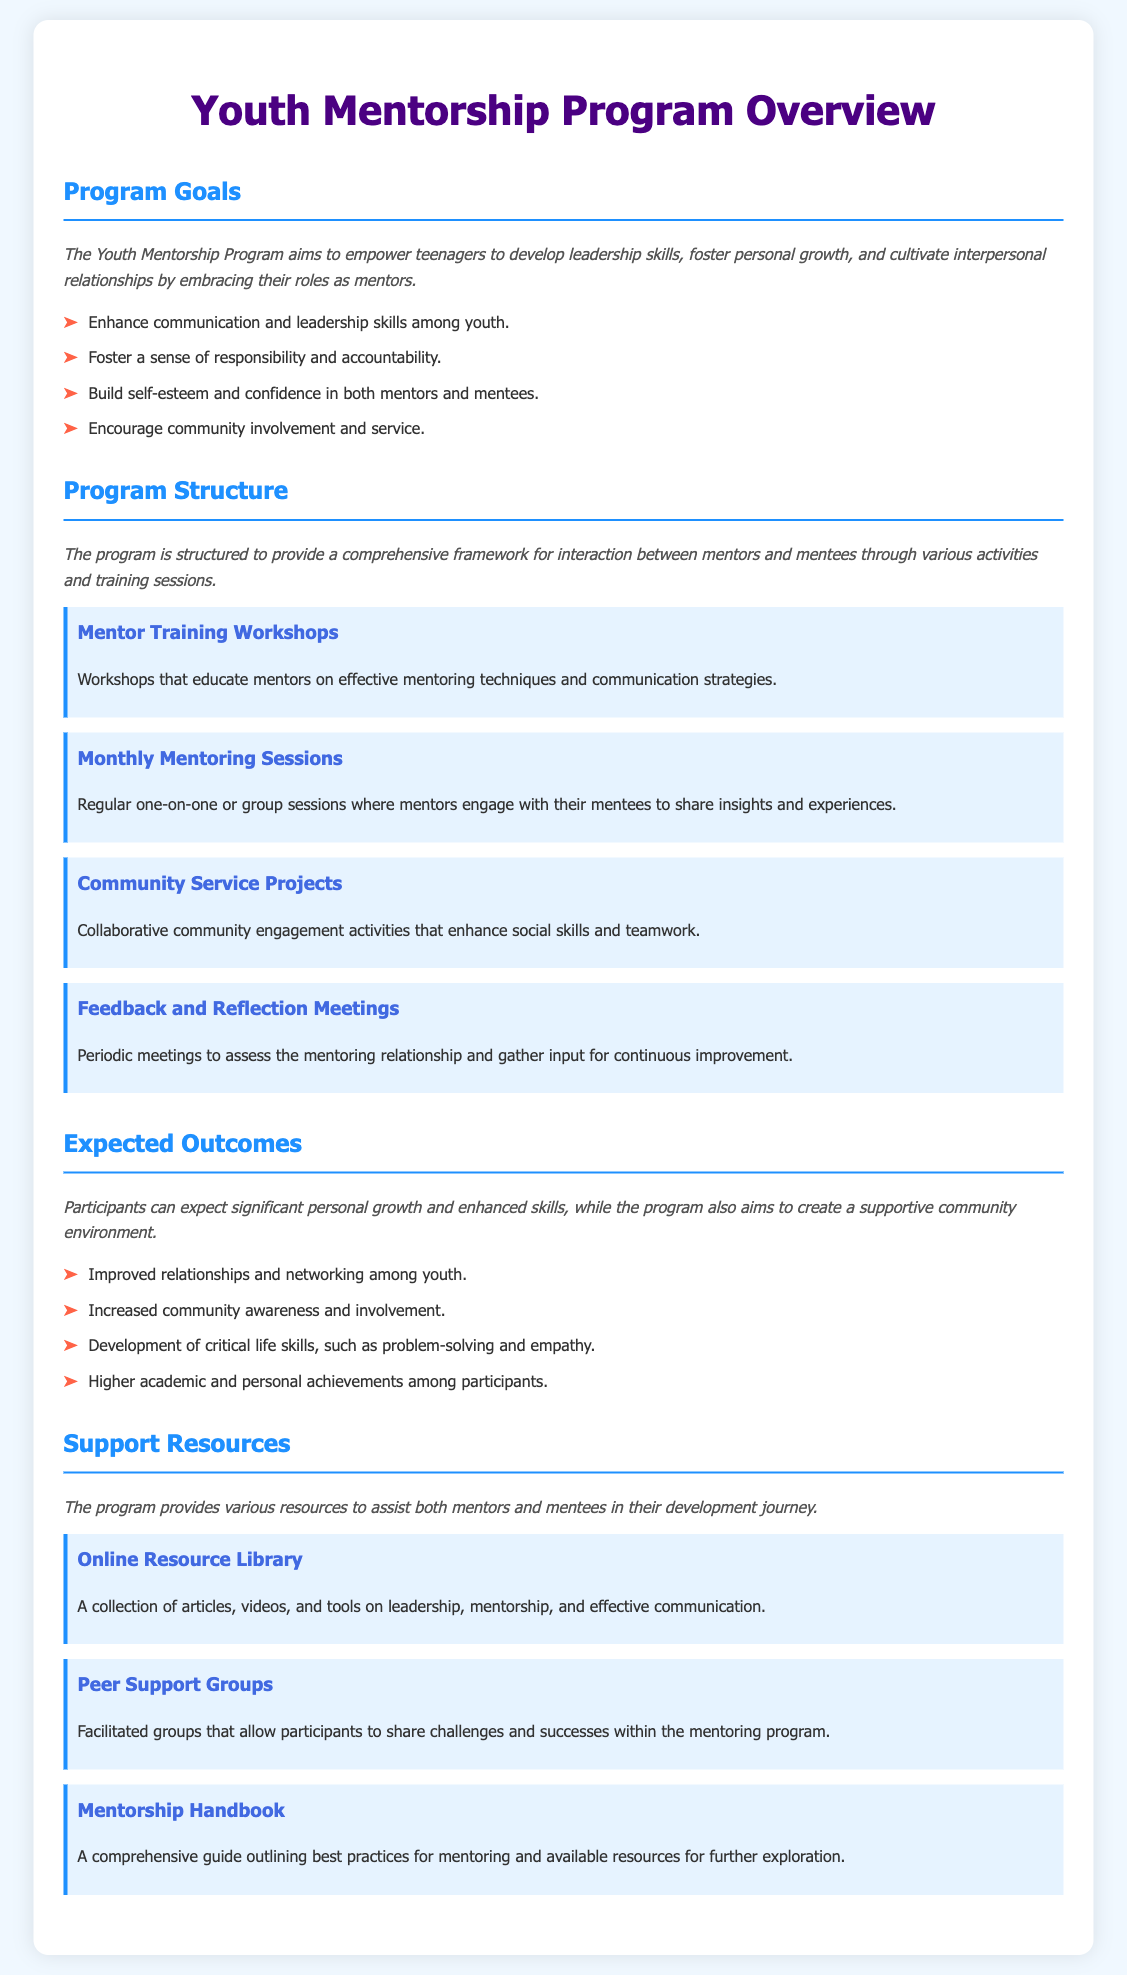what is the main aim of the Youth Mentorship Program? The main aim is to empower teenagers to develop leadership skills, foster personal growth, and cultivate interpersonal relationships by embracing their roles as mentors.
Answer: to empower teenagers how many key components are listed in the Program Structure? The document mentions four key components in the Program Structure section.
Answer: 4 name one expected outcome for participants of the program. One expected outcome is improved relationships and networking among youth.
Answer: improved relationships what type of sessions are described as regular meetings between mentors and mentees? The document describes monthly mentoring sessions as the regular meetings between mentors and mentees.
Answer: Monthly Mentoring Sessions which resource offers articles, videos, and tools on mentorship? The Online Resource Library provides articles, videos, and tools on leadership, mentorship, and effective communication.
Answer: Online Resource Library what kind of projects are included in the program to promote community engagement? Community service projects are included to promote collaborative community engagement activities.
Answer: Community Service Projects how many goals does the program have listed? The document lists four goals for the program.
Answer: 4 what is the purpose of the Feedback and Reflection Meetings? The purpose is to assess the mentoring relationship and gather input for continuous improvement.
Answer: to assess the mentoring relationship name one resource available to assist participants in their development journey. The Mentorship Handbook is a resource available to assist participants.
Answer: Mentorship Handbook 